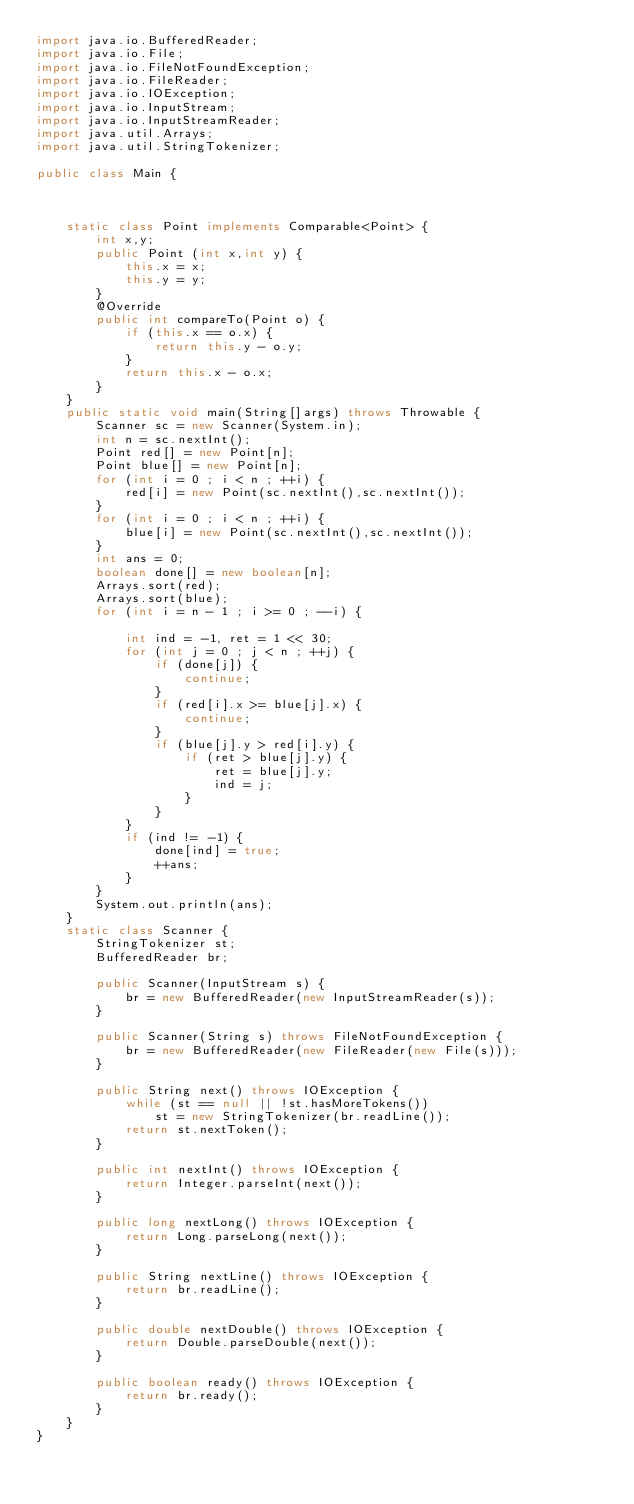Convert code to text. <code><loc_0><loc_0><loc_500><loc_500><_Java_>import java.io.BufferedReader;
import java.io.File;
import java.io.FileNotFoundException;
import java.io.FileReader;
import java.io.IOException;
import java.io.InputStream;
import java.io.InputStreamReader;
import java.util.Arrays;
import java.util.StringTokenizer;

public class Main {

	

	static class Point implements Comparable<Point> {
		int x,y;
		public Point (int x,int y) {
			this.x = x;
			this.y = y;
		}
		@Override
		public int compareTo(Point o) {
			if (this.x == o.x) {
				return this.y - o.y;
			}
			return this.x - o.x;
		}
	}
	public static void main(String[]args) throws Throwable {
		Scanner sc = new Scanner(System.in);
		int n = sc.nextInt();
		Point red[] = new Point[n];
		Point blue[] = new Point[n];
		for (int i = 0 ; i < n ; ++i) {
			red[i] = new Point(sc.nextInt(),sc.nextInt());
		}
		for (int i = 0 ; i < n ; ++i) {
			blue[i] = new Point(sc.nextInt(),sc.nextInt());
		}
		int ans = 0;
		boolean done[] = new boolean[n];
		Arrays.sort(red);
		Arrays.sort(blue);
		for (int i = n - 1 ; i >= 0 ; --i) {
			
			int ind = -1, ret = 1 << 30;
			for (int j = 0 ; j < n ; ++j) {
				if (done[j]) {
					continue;
				}
				if (red[i].x >= blue[j].x) {
					continue;
				}
				if (blue[j].y > red[i].y) {
					if (ret > blue[j].y) {
						ret = blue[j].y;
						ind = j;
					}
				}
			}
			if (ind != -1) {
				done[ind] = true;
				++ans;
			}
		}
		System.out.println(ans);
	}
	static class Scanner {
		StringTokenizer st;
		BufferedReader br;

		public Scanner(InputStream s) {
			br = new BufferedReader(new InputStreamReader(s));
		}

		public Scanner(String s) throws FileNotFoundException {
			br = new BufferedReader(new FileReader(new File(s)));
		}

		public String next() throws IOException {
			while (st == null || !st.hasMoreTokens())
				st = new StringTokenizer(br.readLine());
			return st.nextToken();
		}

		public int nextInt() throws IOException {
			return Integer.parseInt(next());
		}

		public long nextLong() throws IOException {
			return Long.parseLong(next());
		}

		public String nextLine() throws IOException {
			return br.readLine();
		}

		public double nextDouble() throws IOException {
			return Double.parseDouble(next());
		}

		public boolean ready() throws IOException {
			return br.ready();
		}
	}
}
</code> 